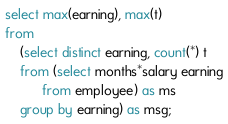Convert code to text. <code><loc_0><loc_0><loc_500><loc_500><_SQL_>select max(earning), max(t)
from
    (select distinct earning, count(*) t
    from (select months*salary earning
          from employee) as ms
    group by earning) as msg;
</code> 